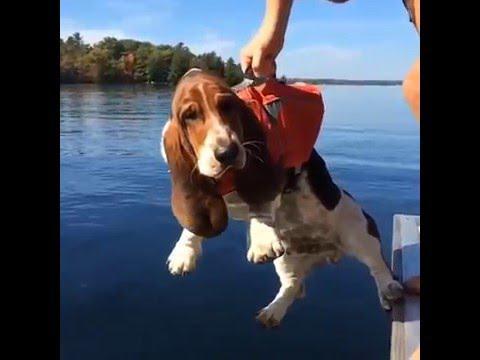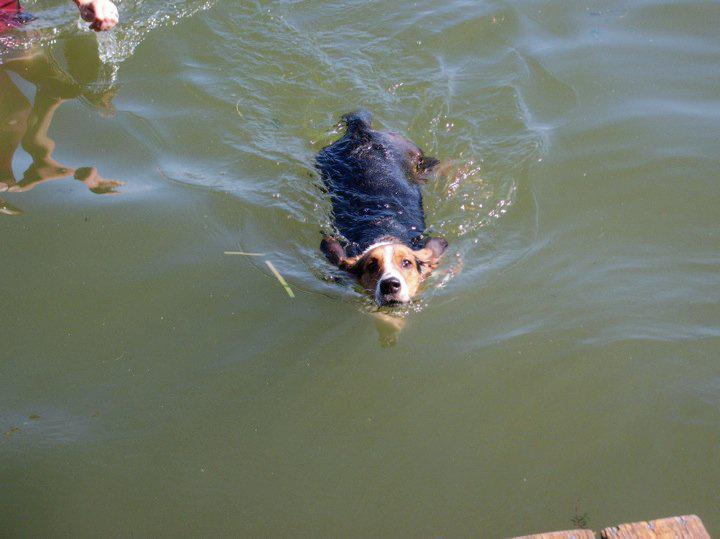The first image is the image on the left, the second image is the image on the right. Given the left and right images, does the statement "The dog in the image on the left is wearing a life jacket." hold true? Answer yes or no. Yes. The first image is the image on the left, the second image is the image on the right. Assess this claim about the two images: "A basset hound is wearing a bright red-orange life vest in a scene that contains water.". Correct or not? Answer yes or no. Yes. 